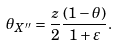<formula> <loc_0><loc_0><loc_500><loc_500>\theta _ { X ^ { \prime \prime } } = \frac { z } { 2 } \frac { ( 1 - \theta ) } { 1 + \varepsilon } .</formula> 